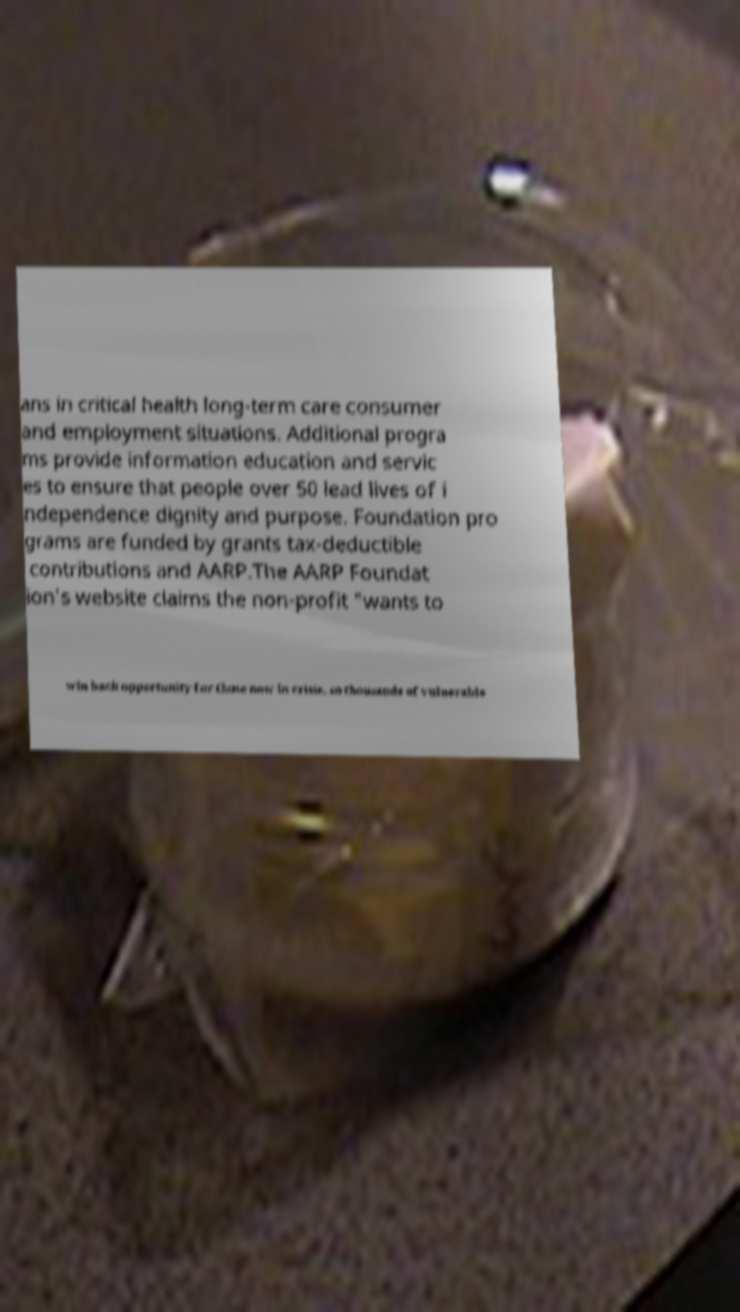There's text embedded in this image that I need extracted. Can you transcribe it verbatim? ans in critical health long-term care consumer and employment situations. Additional progra ms provide information education and servic es to ensure that people over 50 lead lives of i ndependence dignity and purpose. Foundation pro grams are funded by grants tax-deductible contributions and AARP.The AARP Foundat ion's website claims the non-profit "wants to win back opportunity for those now in crisis, so thousands of vulnerable 